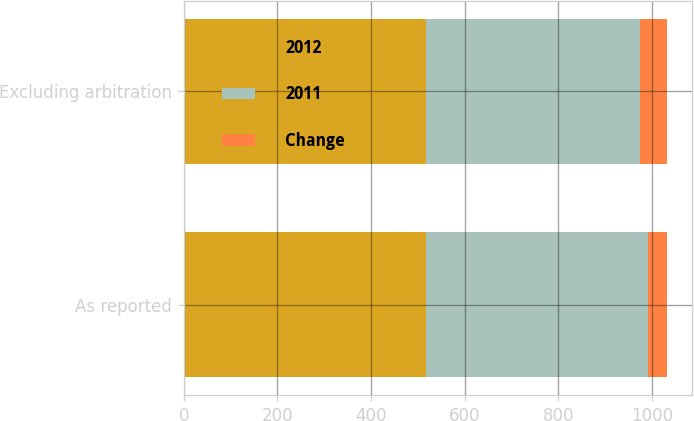Convert chart. <chart><loc_0><loc_0><loc_500><loc_500><stacked_bar_chart><ecel><fcel>As reported<fcel>Excluding arbitration<nl><fcel>2012<fcel>516.4<fcel>516.4<nl><fcel>2011<fcel>475.1<fcel>457.1<nl><fcel>Change<fcel>41.3<fcel>59.3<nl></chart> 